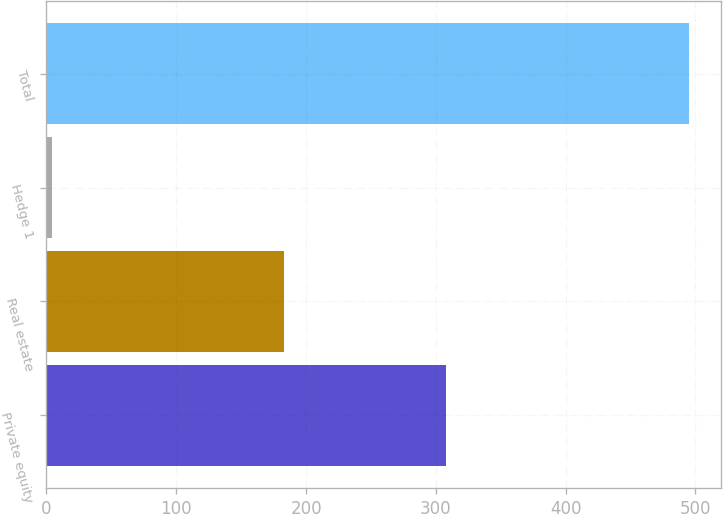<chart> <loc_0><loc_0><loc_500><loc_500><bar_chart><fcel>Private equity<fcel>Real estate<fcel>Hedge 1<fcel>Total<nl><fcel>308<fcel>183<fcel>4<fcel>495<nl></chart> 